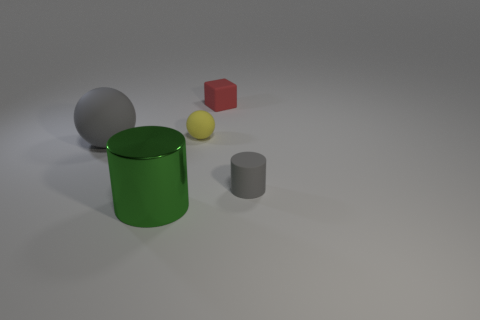Add 2 big cyan matte objects. How many objects exist? 7 Subtract 1 cylinders. How many cylinders are left? 1 Subtract all gray cylinders. How many cylinders are left? 1 Subtract all cubes. How many objects are left? 4 Subtract all tiny matte cubes. Subtract all blocks. How many objects are left? 3 Add 2 small red rubber objects. How many small red rubber objects are left? 3 Add 2 tiny yellow metal spheres. How many tiny yellow metal spheres exist? 2 Subtract 0 gray cubes. How many objects are left? 5 Subtract all gray blocks. Subtract all cyan cylinders. How many blocks are left? 1 Subtract all blue cylinders. How many gray cubes are left? 0 